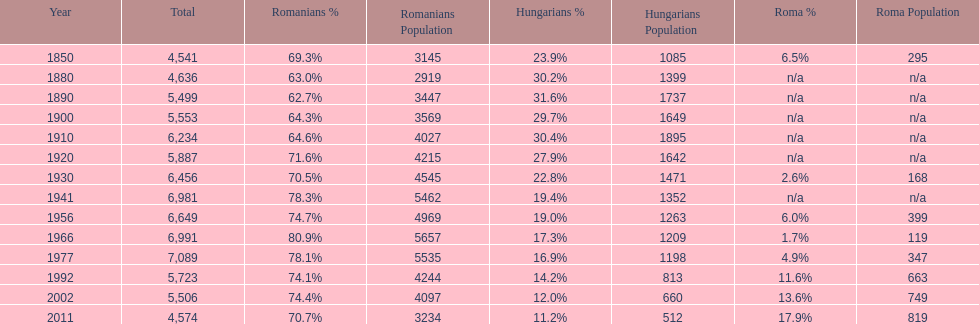Parse the full table. {'header': ['Year', 'Total', 'Romanians %', 'Romanians Population', 'Hungarians %', 'Hungarians Population', 'Roma %', 'Roma Population'], 'rows': [['1850', '4,541', '69.3%', '3145', '23.9%', '1085', '6.5%', '295'], ['1880', '4,636', '63.0%', '2919', '30.2%', '1399', 'n/a', 'n/a'], ['1890', '5,499', '62.7%', '3447', '31.6%', '1737', 'n/a', 'n/a'], ['1900', '5,553', '64.3%', '3569', '29.7%', '1649', 'n/a', 'n/a'], ['1910', '6,234', '64.6%', '4027', '30.4%', '1895', 'n/a', 'n/a'], ['1920', '5,887', '71.6%', '4215', '27.9%', '1642', 'n/a', 'n/a'], ['1930', '6,456', '70.5%', '4545', '22.8%', '1471', '2.6%', '168'], ['1941', '6,981', '78.3%', '5462', '19.4%', '1352', 'n/a', 'n/a'], ['1956', '6,649', '74.7%', '4969', '19.0%', '1263', '6.0%', '399'], ['1966', '6,991', '80.9%', '5657', '17.3%', '1209', '1.7%', '119'], ['1977', '7,089', '78.1%', '5535', '16.9%', '1198', '4.9%', '347'], ['1992', '5,723', '74.1%', '4244', '14.2%', '813', '11.6%', '663'], ['2002', '5,506', '74.4%', '4097', '12.0%', '660', '13.6%', '749'], ['2011', '4,574', '70.7%', '3234', '11.2%', '512', '17.9%', '819']]} Which year is previous to the year that had 74.1% in romanian population? 1977. 